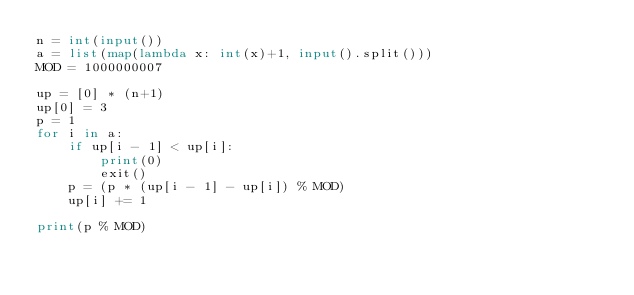Convert code to text. <code><loc_0><loc_0><loc_500><loc_500><_Python_>n = int(input())
a = list(map(lambda x: int(x)+1, input().split()))
MOD = 1000000007

up = [0] * (n+1)
up[0] = 3
p = 1
for i in a:
    if up[i - 1] < up[i]:
        print(0)
        exit()
    p = (p * (up[i - 1] - up[i]) % MOD)
    up[i] += 1

print(p % MOD)
</code> 